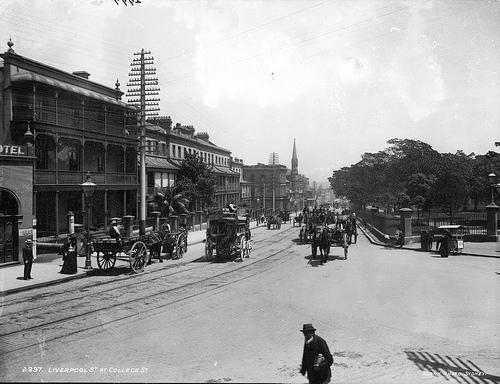Is the street busy?
Keep it brief. Yes. Where are the horses?
Answer briefly. Street. Was Elvis born yet?
Write a very short answer. No. Is this picture old?
Answer briefly. Yes. How many wagons are present?
Quick response, please. 3. How old is this picture?
Quick response, please. 178. Will any children be skiing?
Be succinct. No. Is this a color photo?
Short answer required. No. Is the road clear?
Write a very short answer. No. 